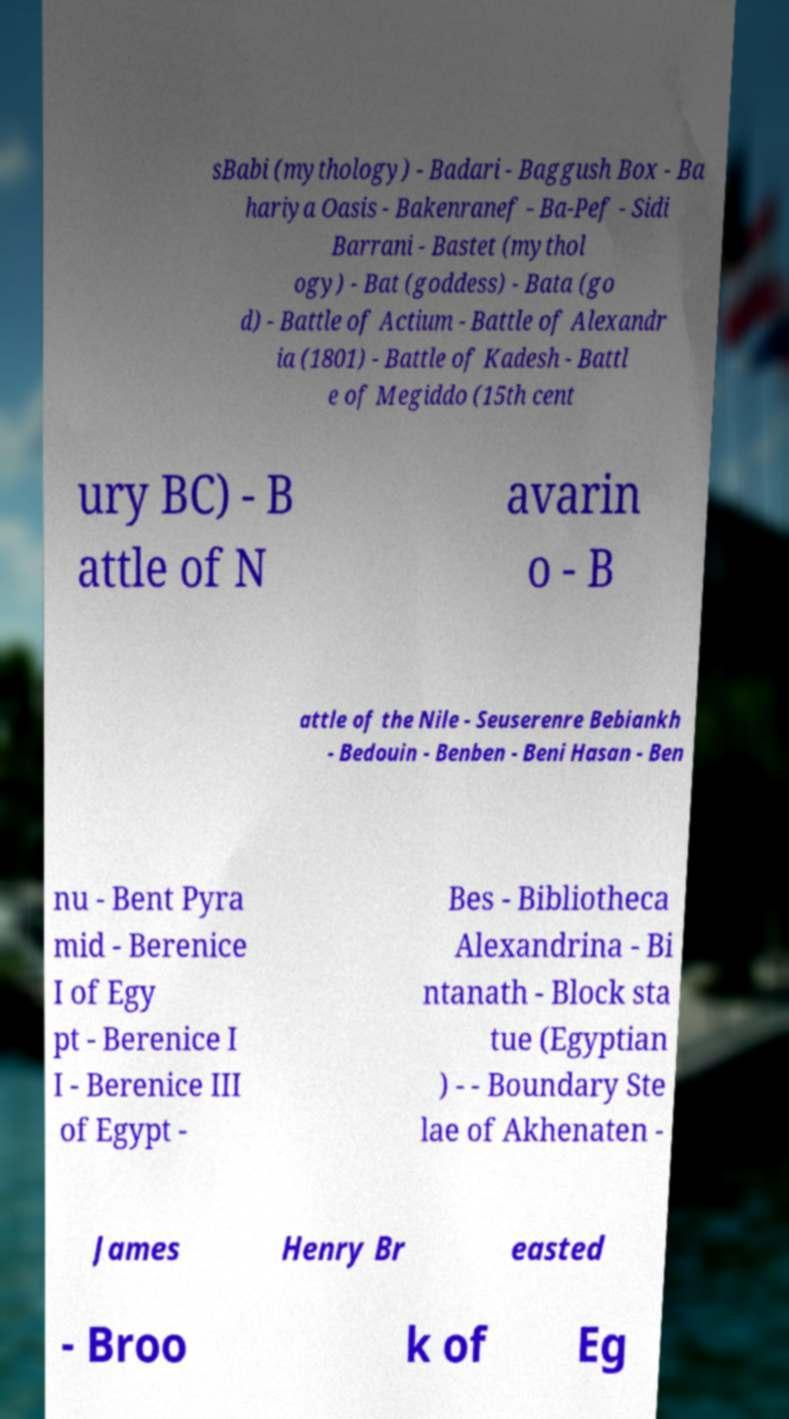Please read and relay the text visible in this image. What does it say? sBabi (mythology) - Badari - Baggush Box - Ba hariya Oasis - Bakenranef - Ba-Pef - Sidi Barrani - Bastet (mythol ogy) - Bat (goddess) - Bata (go d) - Battle of Actium - Battle of Alexandr ia (1801) - Battle of Kadesh - Battl e of Megiddo (15th cent ury BC) - B attle of N avarin o - B attle of the Nile - Seuserenre Bebiankh - Bedouin - Benben - Beni Hasan - Ben nu - Bent Pyra mid - Berenice I of Egy pt - Berenice I I - Berenice III of Egypt - Bes - Bibliotheca Alexandrina - Bi ntanath - Block sta tue (Egyptian ) - - Boundary Ste lae of Akhenaten - James Henry Br easted - Broo k of Eg 